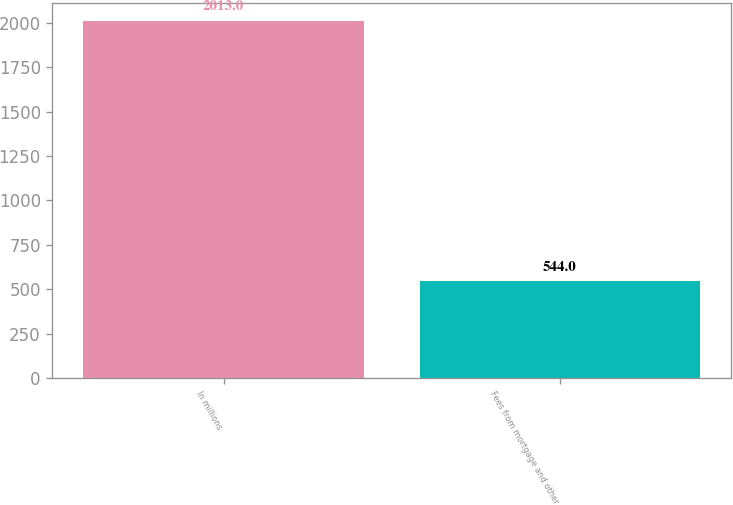Convert chart. <chart><loc_0><loc_0><loc_500><loc_500><bar_chart><fcel>In millions<fcel>Fees from mortgage and other<nl><fcel>2013<fcel>544<nl></chart> 